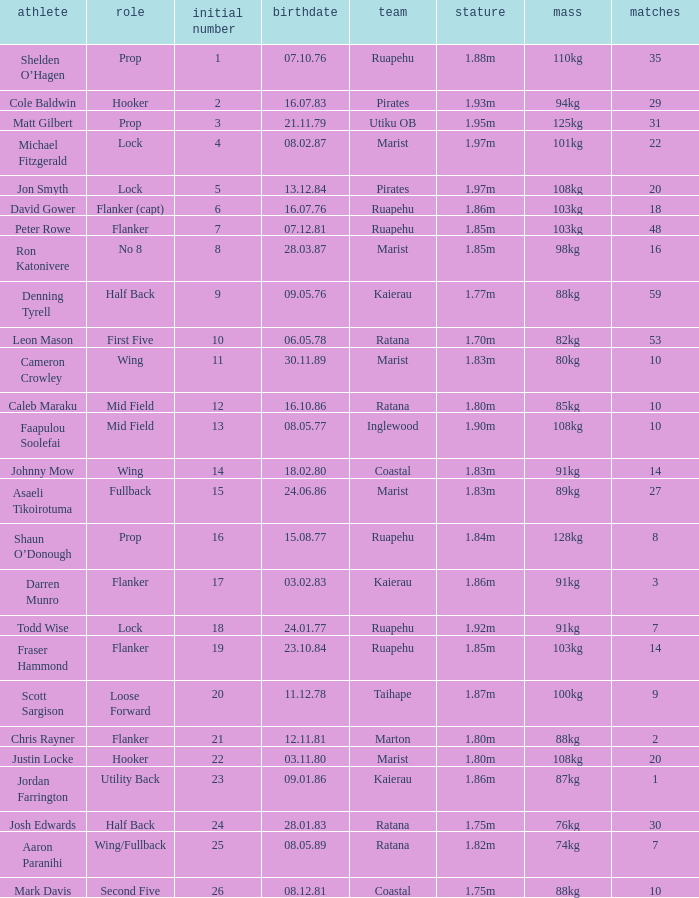How many games were played where the height of the player is 1.92m? 1.0. 